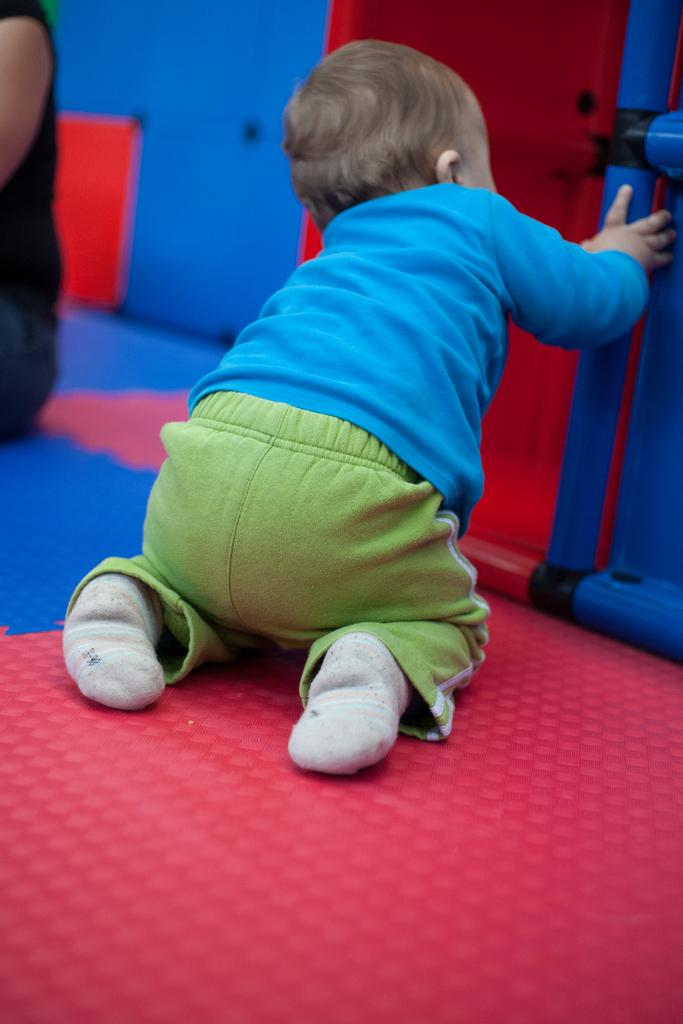What is the main subject of the image? The main subject of the image is a kid sitting. What is the kid holding in the image? The kid is holding an object. Can you describe any other elements in the image? There is a hand of a person on the left side of the image. What type of square badge can be seen in the argument between the kid and the person in the image? There is no square badge or argument present in the image. 